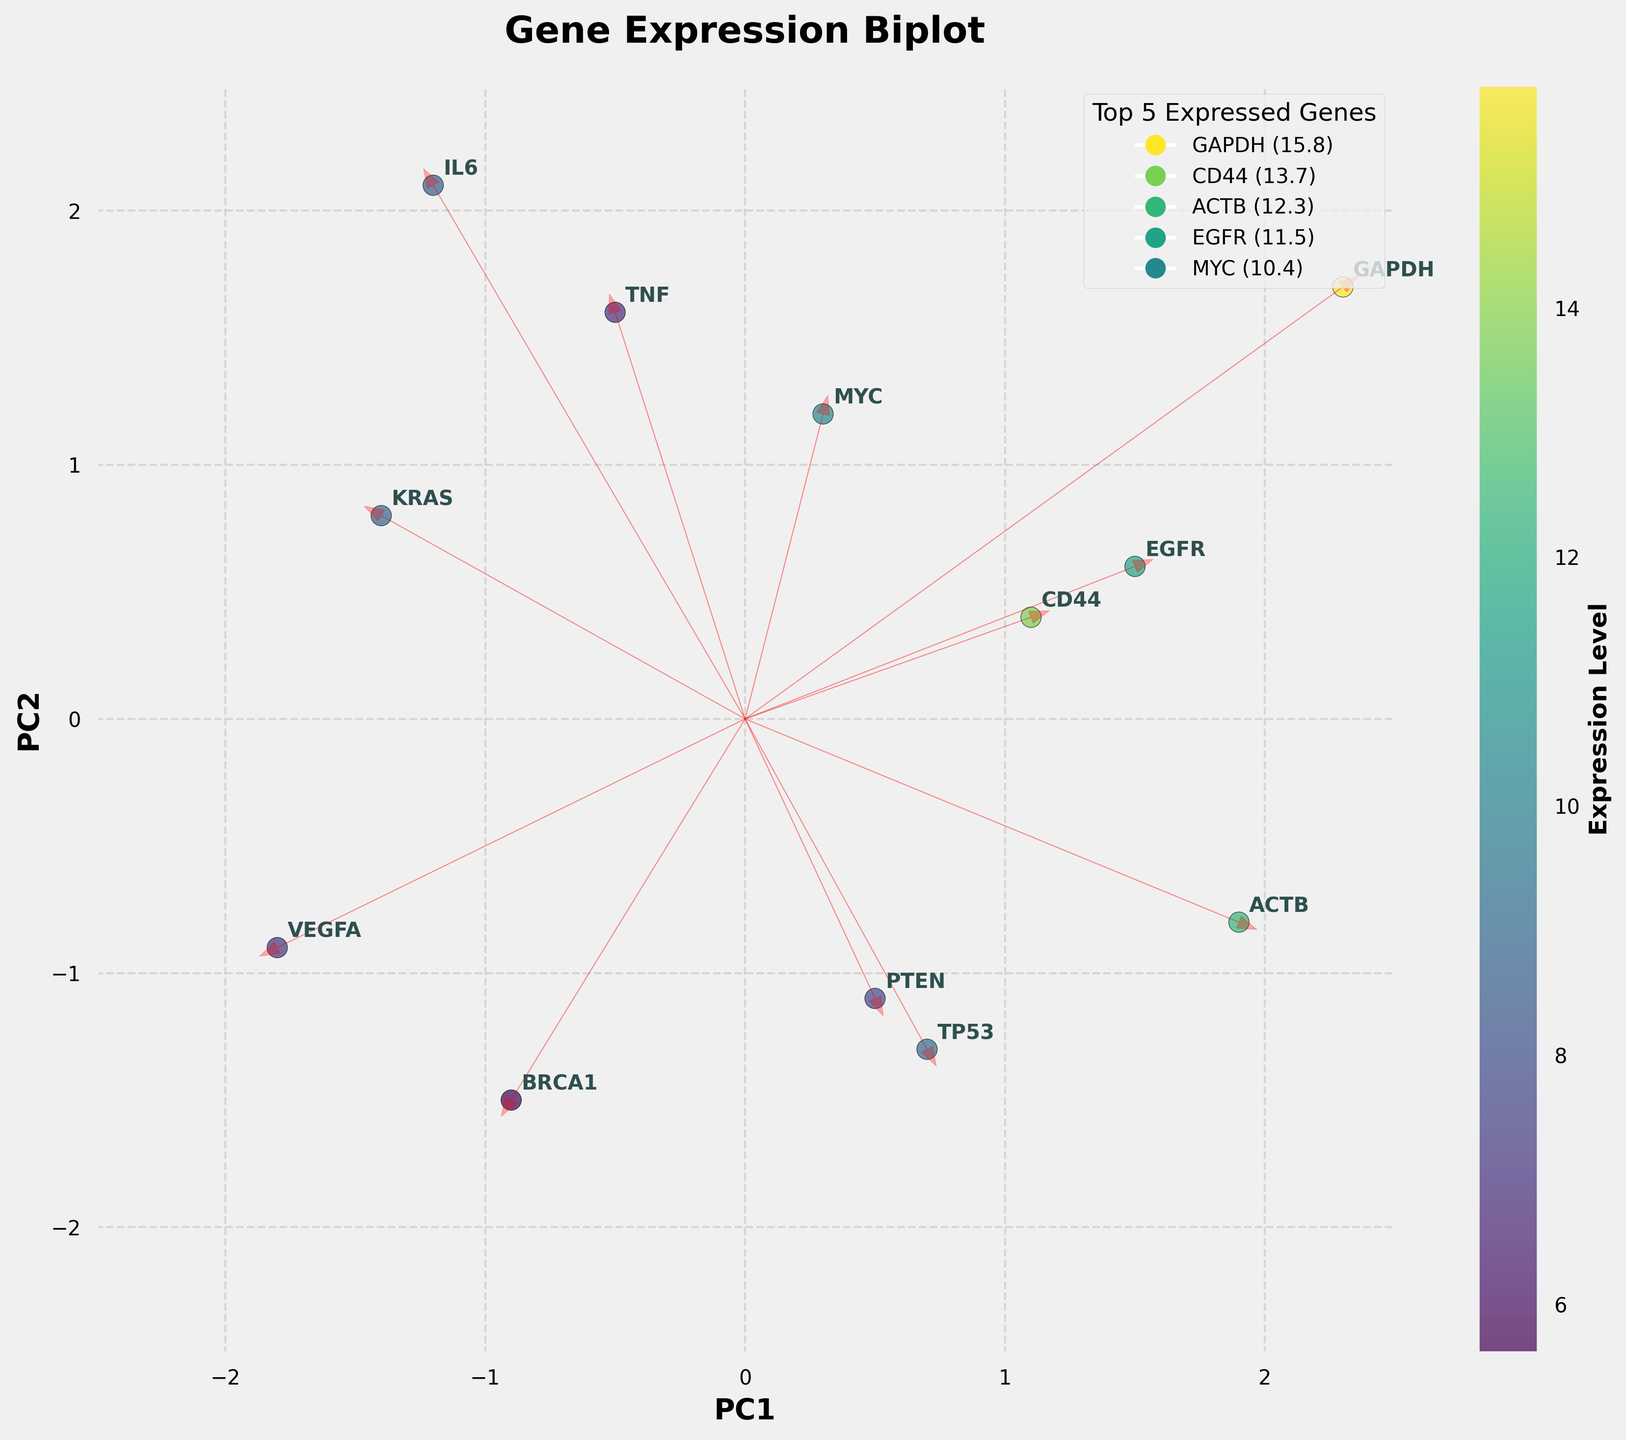What is the title of the figure? The title of the figure is displayed at the top center of the plot.
Answer: Gene Expression Biplot How many genes are represented in the biplot? Each gene is marked by an annotation on the plot; counting these annotations gives the total number of genes.
Answer: 12 Which gene has the highest expression level? The color intensity and the color bar indicate the expression levels; the gene with the darkest color has the highest expression level.
Answer: GAPDH What are the coordinates of the gene ACTB in the PC1-PC2 plane? Find the label "ACTB" on the plot; its coordinates are given as (PC1, PC2).
Answer: (1.9, -0.8) Which gene has the lowest expression level, and what is its position in the PC1-PC2 plane? The color intensity and color bar indicate the expression levels; the gene with the lightest color has the lowest expression level. Find its position in the plot.
Answer: BRCA1, (-0.9, -1.5) Are there any genes with a negative coordinate for both PC1 and PC2? If yes, which ones? Check the coordinates of each gene; if both PC1 and PC2 values are negative, note the respective gene.
Answer: VEGFA, BRCA1 What is the range of PC1 values in the plot? From the plot, identify the minimum and maximum PC1 values to determine the range.
Answer: -1.8 to 2.3 Which gene is closest to the origin (0, 0) in the plot? Calculate the Euclidean distance from the origin to each gene, and identify the gene with the smallest distance.
Answer: MYC Which two genes are furthest apart in the PC1-PC2 plane? Calculate the Euclidean distance between every pair of genes, and find the pair with the greatest distance.
Answer: GAPDH and VEGFA What is the average expression level of the top 5 expressed genes? Identify the top 5 expressed genes from the color intensity or legend, sum their expression levels, and divide by 5 to calculate the average.
Answer: 12.7 